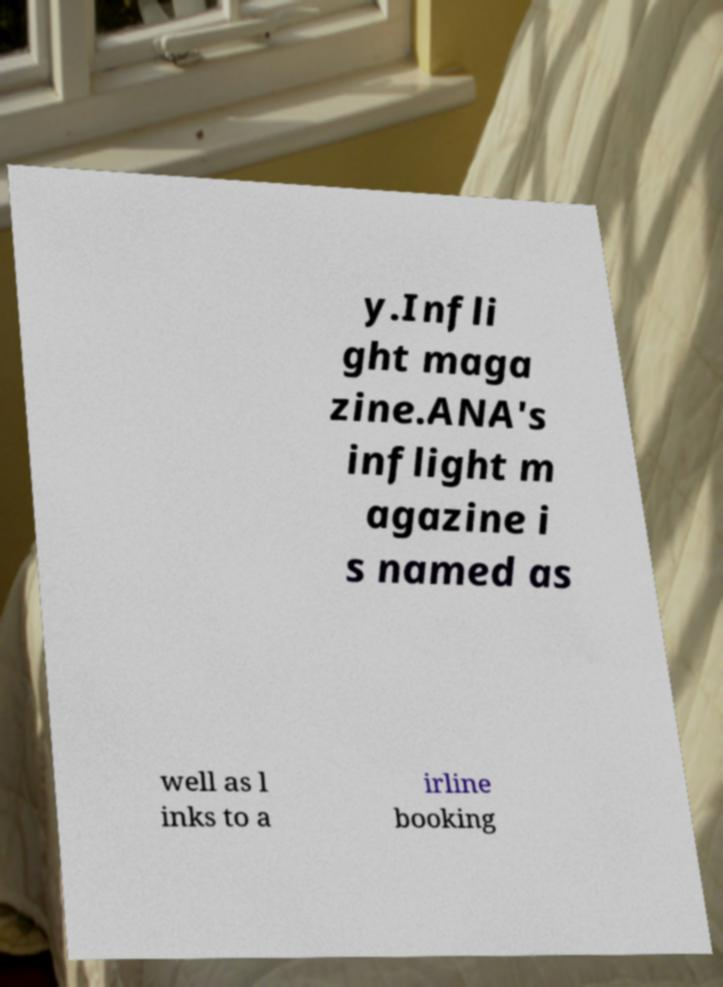I need the written content from this picture converted into text. Can you do that? y.Infli ght maga zine.ANA's inflight m agazine i s named as well as l inks to a irline booking 